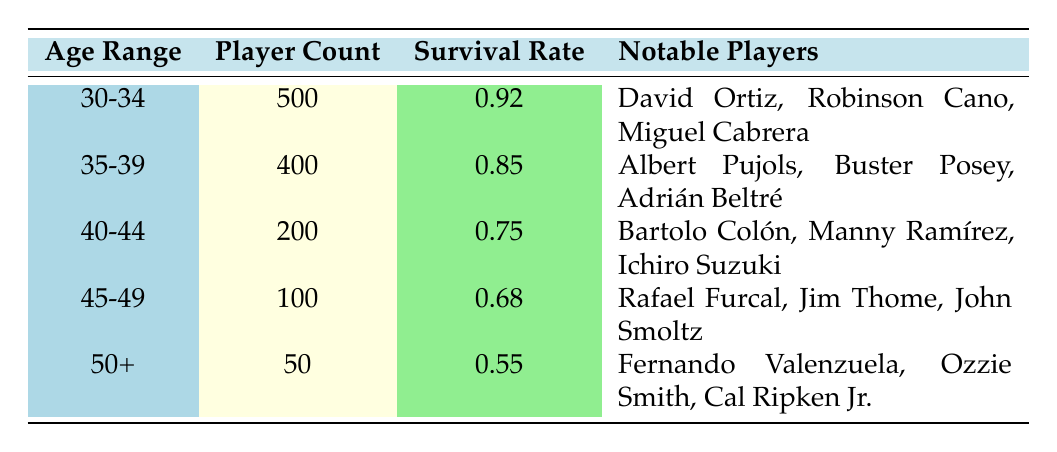What is the survival rate for players aged 30-34? According to the table, the survival rate for the age range 30-34 is listed directly under the "Survival Rate" column. The value given for this age range is 0.92.
Answer: 0.92 How many players are there in the age range 40-44? The table lists the player count for the age range 40-44 in the "Player Count" column. The corresponding value for this range is 200.
Answer: 200 Which age category has the lowest survival rate? By examining the "Survival Rate" column of the table, the age category with the lowest rate can be identified. The age range 50+ has the lowest survival rate of 0.55.
Answer: 50+ Is there a notable player from the age group 35-39? The table provides a list of notable players for each age range. For the age group 35-39, Albert Pujols is listed as a notable player, making the statement true.
Answer: Yes What is the average survival rate for all age groups? To find the average survival rate, first, sum the survival rates: 0.92 + 0.85 + 0.75 + 0.68 + 0.55 = 3.75. Then, divide this sum by the number of age ranges (which is 5): 3.75 / 5 = 0.75. Therefore, the average survival rate is 0.75.
Answer: 0.75 How many players aged 50 or older have a survival rate above 0.50? Looking at the table, only the age group 50+ has a player count of 50 and a survival rate of 0.55. Since this is above 0.50, the total players in this age range is 50.
Answer: 50 Which age category has the same number of prominent players as the number of players it represents? If you count the notable players listed in each age group, the age range 30-34 has three notable players (David Ortiz, Robinson Cano, Miguel Cabrera) and has 500 players overall. However, there is no category where the count matches, making the answer none.
Answer: None Are there any notable players who played after age 45? From the table, both the age groups 45-49 and 50+ list notable players. For 45-49, notable players include Rafael Furcal, Jim Thome, and John Smoltz. For 50+, they are Fernando Valenzuela, Ozzie Smith, and Cal Ripken Jr. Hence, there are notable players aged 45 and above.
Answer: Yes 